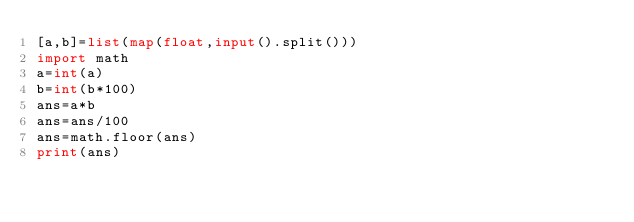<code> <loc_0><loc_0><loc_500><loc_500><_Python_>[a,b]=list(map(float,input().split()))
import math
a=int(a)
b=int(b*100)
ans=a*b
ans=ans/100
ans=math.floor(ans)
print(ans)</code> 